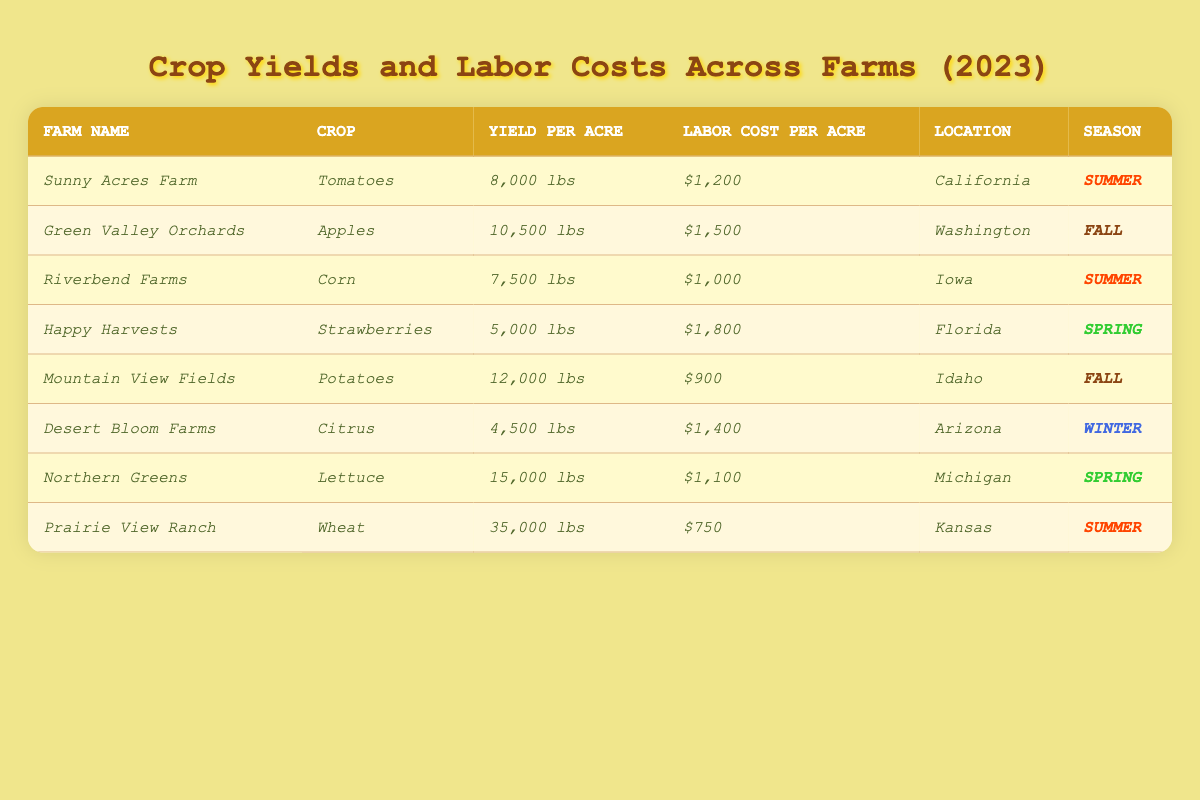What is the farm with the highest crop yield per acre? From the table, the highest yield per acre is 35,000 lbs from Prairie View Ranch for Wheat.
Answer: Prairie View Ranch Which crop has the lowest yield per acre? The lowest yield per acre is 4,500 lbs from Desert Bloom Farms for Citrus.
Answer: Citrus What is the labor cost per acre for Mountain View Fields? The labor cost per acre for Mountain View Fields is $900.
Answer: $900 Which farm is located in California? Sunny Acres Farm is located in California.
Answer: Sunny Acres Farm What is the total yield per acre of Tomatoes and Strawberries? The yield for Tomatoes is 8,000 lbs and for Strawberries is 5,000 lbs. Adding them gives 8,000 + 5,000 = 13,000 lbs.
Answer: 13,000 lbs What is the average labor cost per acre across all farms? The labor costs are $1,200, $1,500, $1,000, $1,800, $900, $1,400, $1,100, and $750. Adding them gives $1,200 + $1,500 + $1,000 + $1,800 + $900 + $1,400 + $1,100 + $750 = $9,650. There are 8 farms, so $9,650 / 8 = $1,206.25.
Answer: $1,206.25 Is there any farm with a labor cost below $1,000 per acre? No, the lowest labor cost is $750 for Prairie View Ranch, which is below $1,000.
Answer: Yes How much more labor cost does Happy Harvests have compared to Riverbend Farms? Happy Harvests has a labor cost of $1,800, while Riverbend Farms has $1,000. The difference is $1,800 - $1,000 = $800.
Answer: $800 Which crop has the highest labor cost per acre and what is that cost? The highest labor cost per acre is $1,800 for Strawberries from Happy Harvests.
Answer: $1,800 How many crops are listed for farms located in Spring? The crops listed for farms in Spring are Strawberries from Happy Harvests and Lettuce from Northern Greens. There are 2 crops.
Answer: 2 Is the yield per acre for Lettuce greater than the yield for Corn? The yield for Lettuce is 15,000 lbs, while for Corn it is 7,500 lbs. Since 15,000 > 7,500, this statement is true.
Answer: Yes 